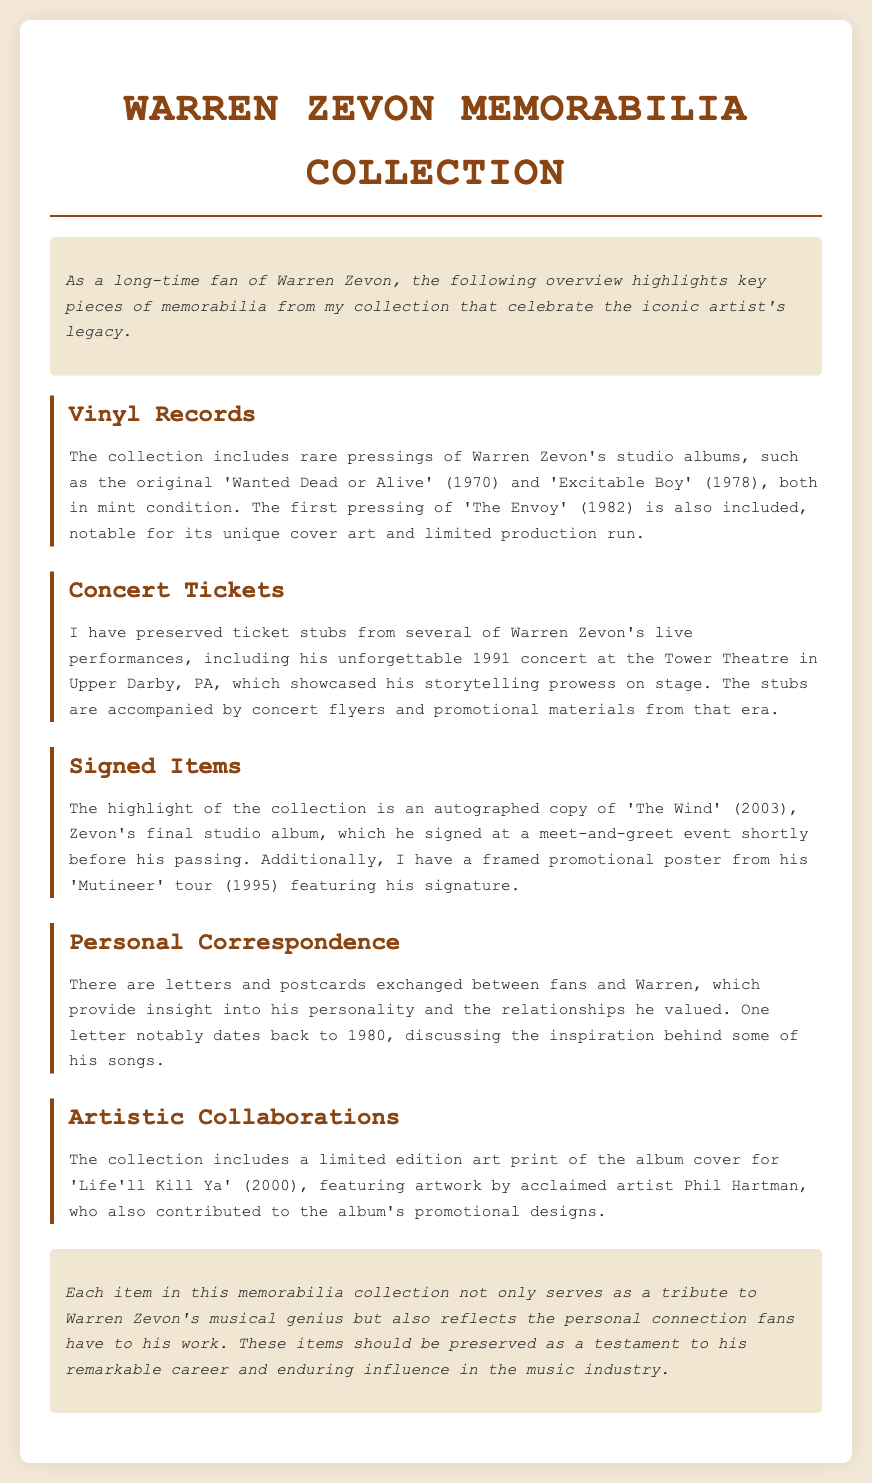What are the rare pressings mentioned? The document specifically highlights the rare pressings of 'Wanted Dead or Alive' (1970) and 'Excitable Boy' (1978).
Answer: 'Wanted Dead or Alive', 'Excitable Boy' What year was 'The Wind' released? The autographed item mentioned is 'The Wind', which is the final studio album released in 2003.
Answer: 2003 What concert is highlighted in the ticket stubs? The memorable concert noted in the document is the 1991 performance at the Tower Theatre in Upper Darby, PA.
Answer: Tower Theatre, Upper Darby, PA What notable item is mentioned related to 'Mutineer' tour? A framed promotional poster featuring Warren Zevon's signature from his 'Mutineer' tour is included.
Answer: Framed promotional poster Who provided the artwork for 'Life'll Kill Ya'? The limited edition art print for 'Life'll Kill Ya' is created by the acclaimed artist Phil Hartman.
Answer: Phil Hartman What type of correspondence is included in the collection? The collection features personal letters and postcards exchanged between fans and Warren Zevon.
Answer: Letters and postcards How many concert tickets are mentioned in the document? While the document mentions ticket stubs, it does not specify a number, indicating multiple tickets from different performances.
Answer: Multiple What is the introduction focused on? The introduction emphasizes an overview of key memorabilia pieces celebrating Warren Zevon's legacy.
Answer: Overview of key memorabilia pieces What is meant to be preserved according to the conclusion? The conclusion stresses that the items should be preserved as a testament to Zevon's remarkable career and influence.
Answer: Items should be preserved 